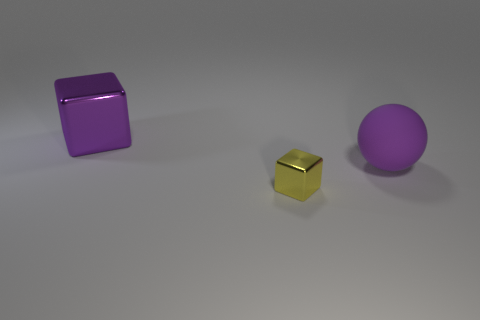Can you describe the textures of the objects shown? Certainly! The purple cube on the left appears to have a matte finish, giving it a non-reflective surface texture. The small golden cube in the center has a reflective metallic surface, likely indicating a smooth and shiny texture. Finally, the purple sphere on the right also seems to have a smooth, matte finish, albeit with a slight sheen that suggests it may be slightly reflective under direct light. 